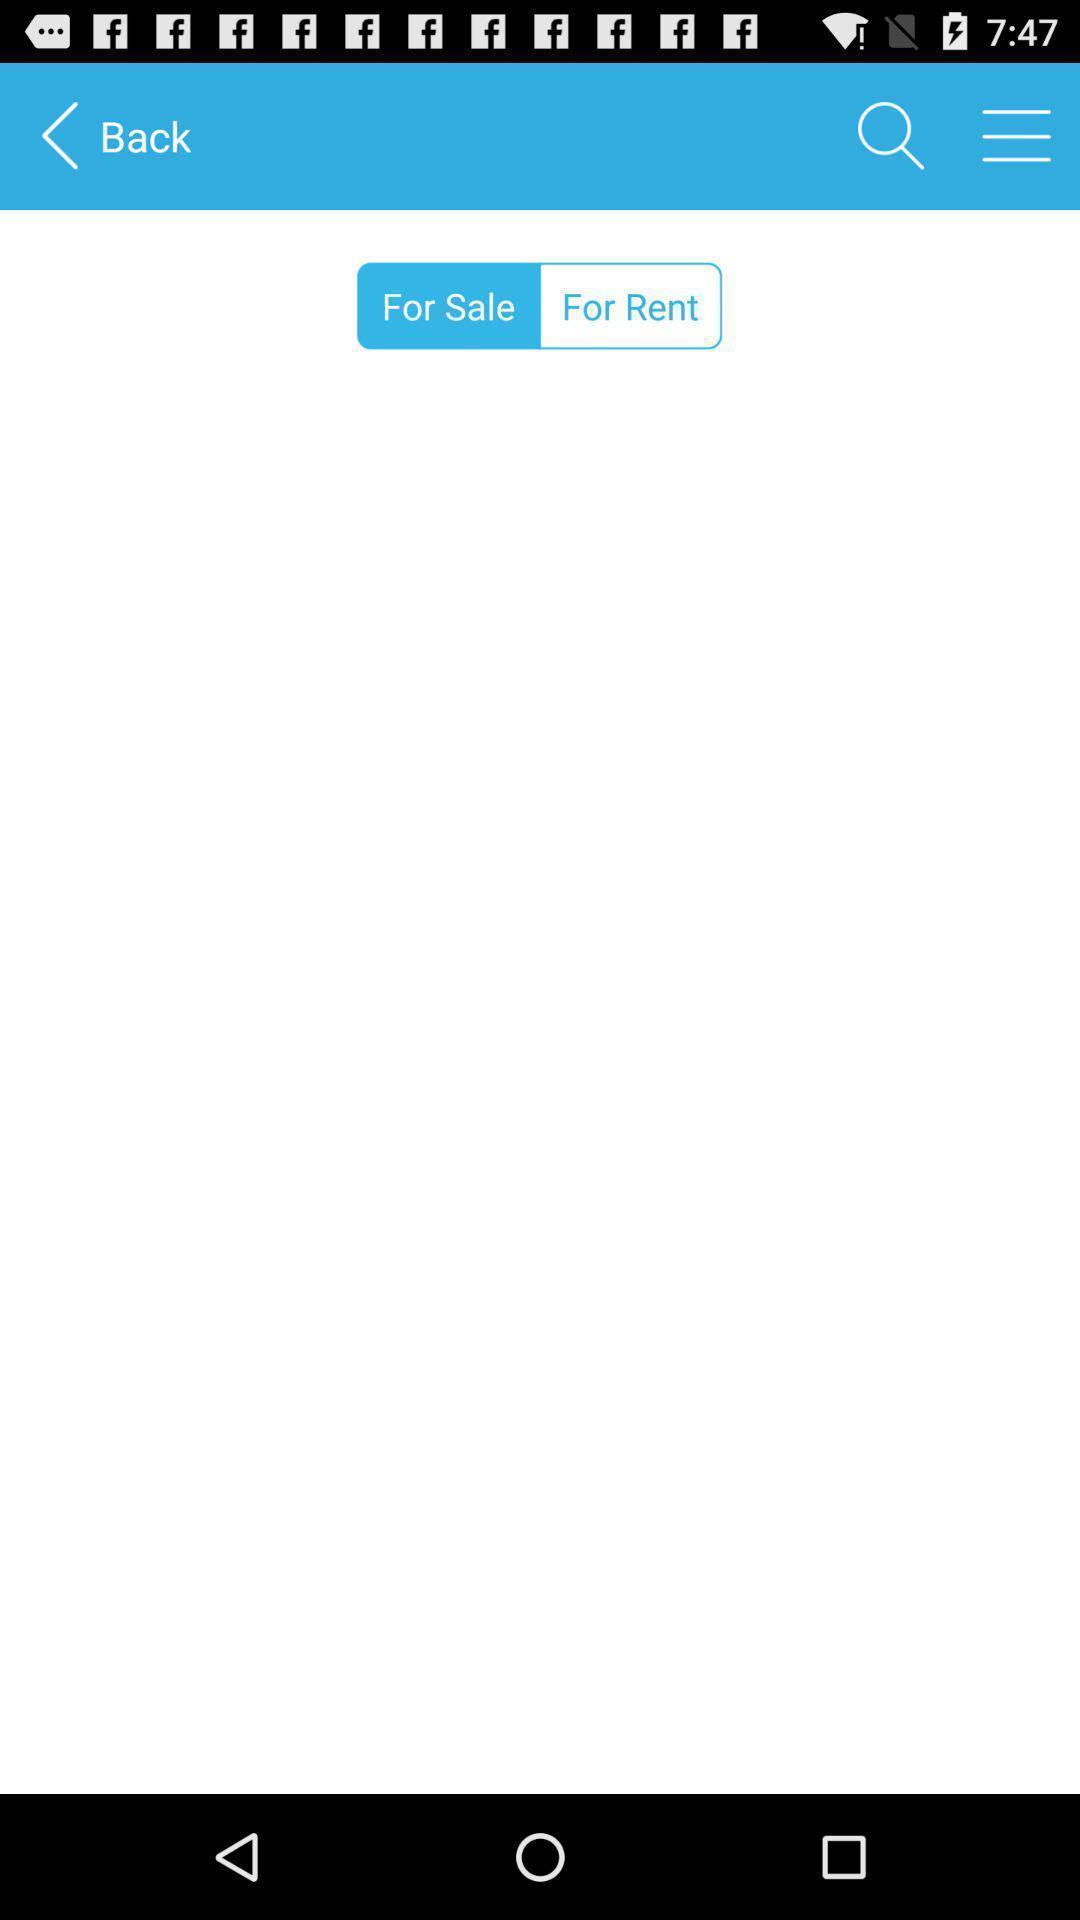Describe the key features of this screenshot. Screen displaying search bar and other options. 